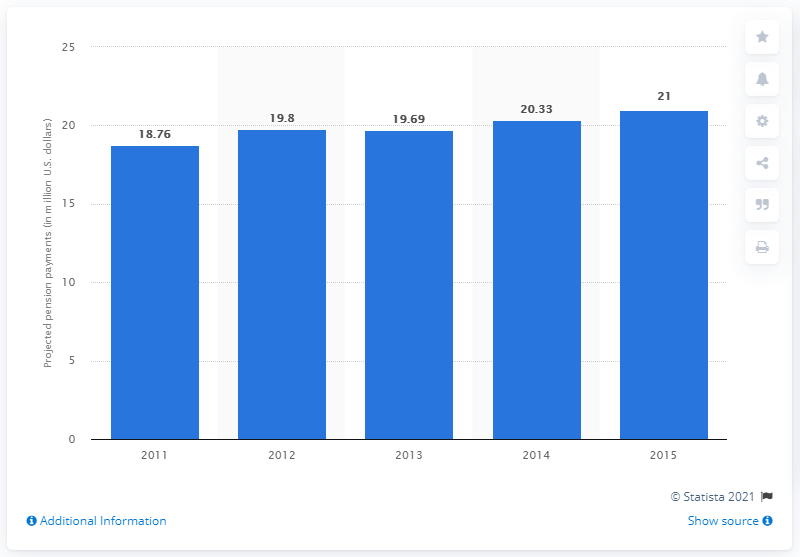Mention a couple of crucial points in this snapshot. In 2013, Hasbro's projected pension payments totaled approximately $19.69 million. 